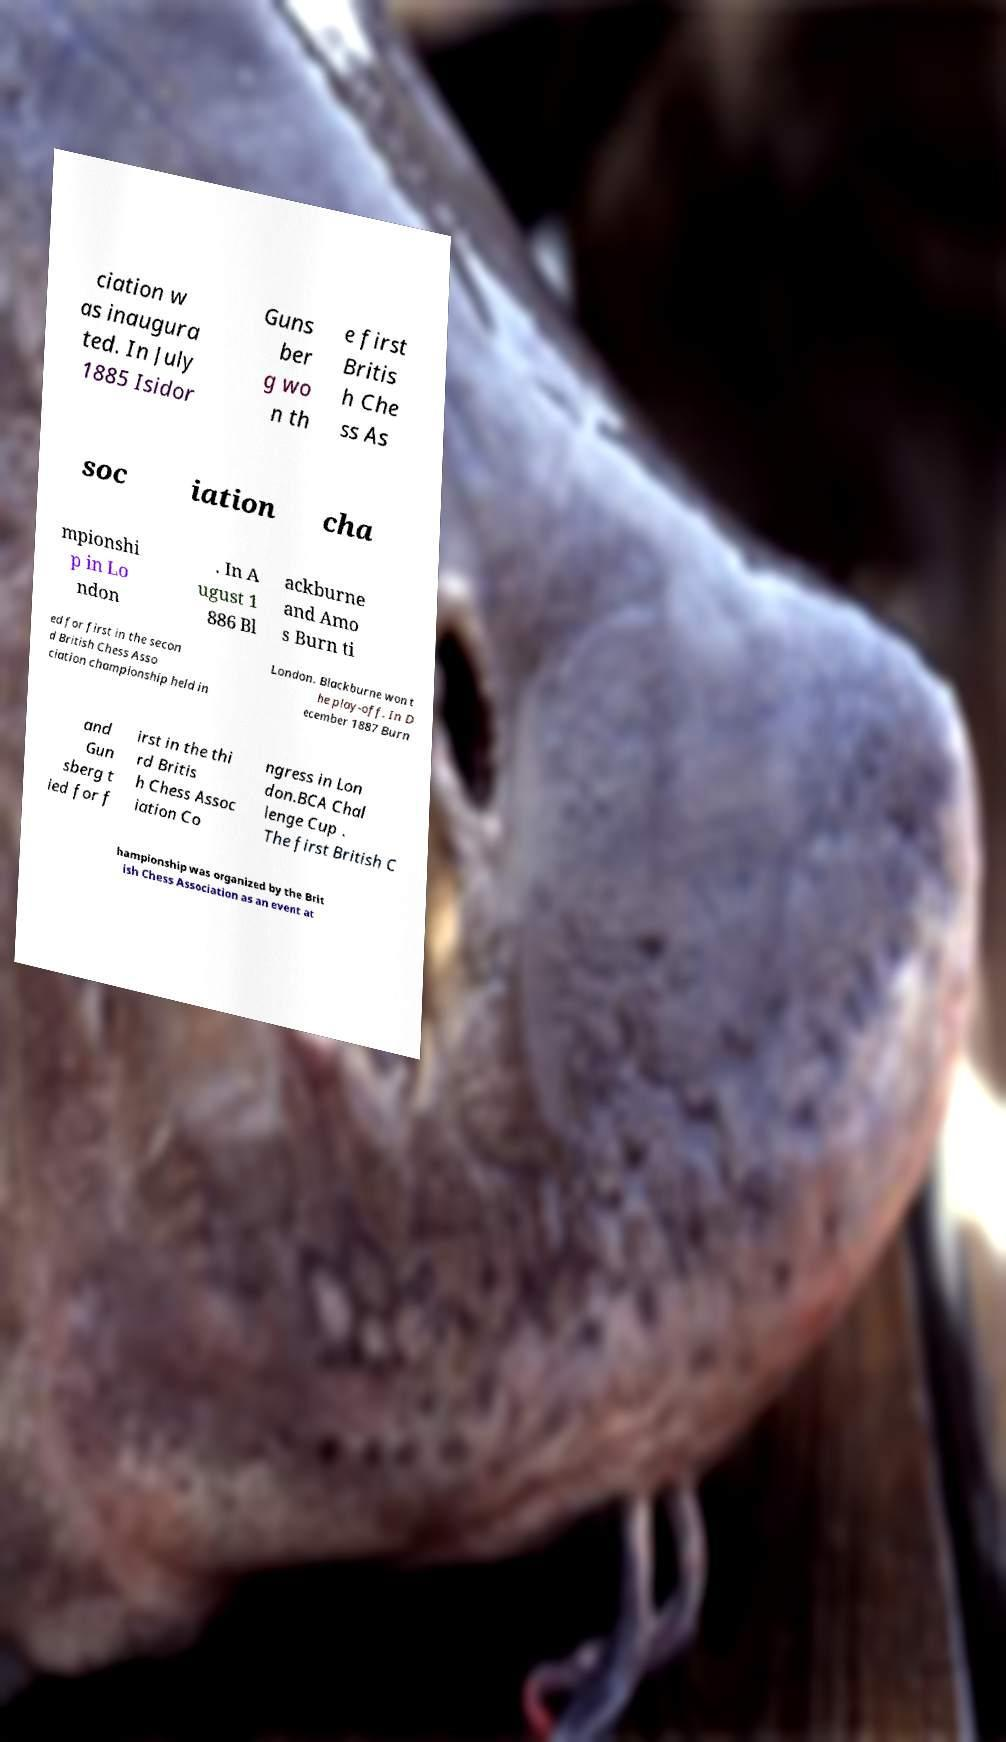For documentation purposes, I need the text within this image transcribed. Could you provide that? ciation w as inaugura ted. In July 1885 Isidor Guns ber g wo n th e first Britis h Che ss As soc iation cha mpionshi p in Lo ndon . In A ugust 1 886 Bl ackburne and Amo s Burn ti ed for first in the secon d British Chess Asso ciation championship held in London. Blackburne won t he play-off. In D ecember 1887 Burn and Gun sberg t ied for f irst in the thi rd Britis h Chess Assoc iation Co ngress in Lon don.BCA Chal lenge Cup . The first British C hampionship was organized by the Brit ish Chess Association as an event at 